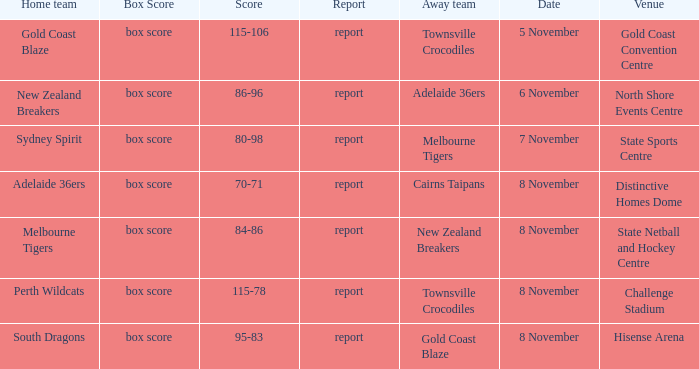What was the date that featured a game against Gold Coast Blaze? 8 November. Would you mind parsing the complete table? {'header': ['Home team', 'Box Score', 'Score', 'Report', 'Away team', 'Date', 'Venue'], 'rows': [['Gold Coast Blaze', 'box score', '115-106', 'report', 'Townsville Crocodiles', '5 November', 'Gold Coast Convention Centre'], ['New Zealand Breakers', 'box score', '86-96', 'report', 'Adelaide 36ers', '6 November', 'North Shore Events Centre'], ['Sydney Spirit', 'box score', '80-98', 'report', 'Melbourne Tigers', '7 November', 'State Sports Centre'], ['Adelaide 36ers', 'box score', '70-71', 'report', 'Cairns Taipans', '8 November', 'Distinctive Homes Dome'], ['Melbourne Tigers', 'box score', '84-86', 'report', 'New Zealand Breakers', '8 November', 'State Netball and Hockey Centre'], ['Perth Wildcats', 'box score', '115-78', 'report', 'Townsville Crocodiles', '8 November', 'Challenge Stadium'], ['South Dragons', 'box score', '95-83', 'report', 'Gold Coast Blaze', '8 November', 'Hisense Arena']]} 